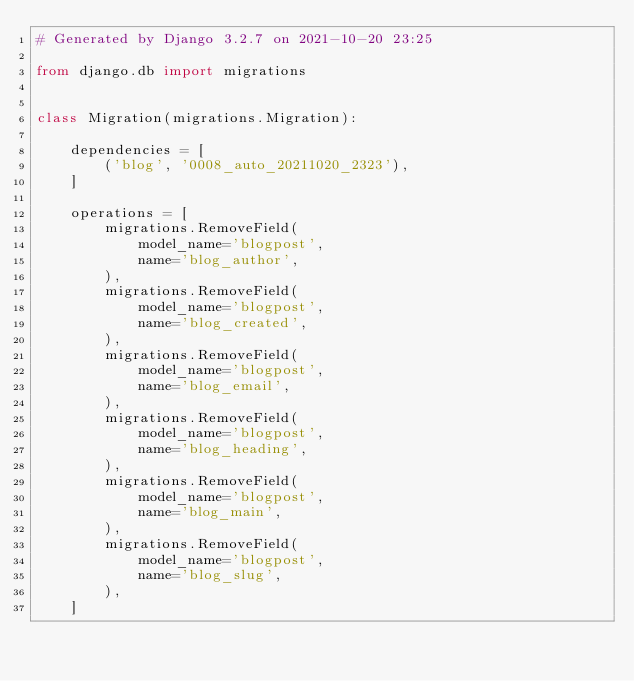<code> <loc_0><loc_0><loc_500><loc_500><_Python_># Generated by Django 3.2.7 on 2021-10-20 23:25

from django.db import migrations


class Migration(migrations.Migration):

    dependencies = [
        ('blog', '0008_auto_20211020_2323'),
    ]

    operations = [
        migrations.RemoveField(
            model_name='blogpost',
            name='blog_author',
        ),
        migrations.RemoveField(
            model_name='blogpost',
            name='blog_created',
        ),
        migrations.RemoveField(
            model_name='blogpost',
            name='blog_email',
        ),
        migrations.RemoveField(
            model_name='blogpost',
            name='blog_heading',
        ),
        migrations.RemoveField(
            model_name='blogpost',
            name='blog_main',
        ),
        migrations.RemoveField(
            model_name='blogpost',
            name='blog_slug',
        ),
    ]
</code> 